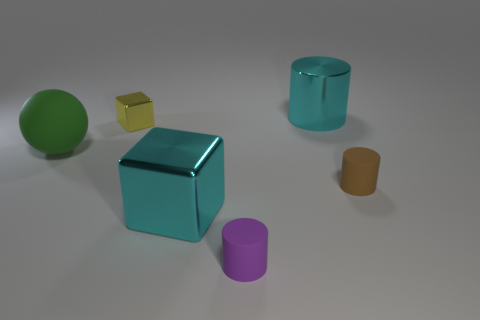Subtract all brown rubber cylinders. How many cylinders are left? 2 Subtract 1 cylinders. How many cylinders are left? 2 Add 4 large red cylinders. How many objects exist? 10 Subtract all balls. How many objects are left? 5 Subtract 0 gray cylinders. How many objects are left? 6 Subtract all spheres. Subtract all tiny objects. How many objects are left? 2 Add 5 tiny cubes. How many tiny cubes are left? 6 Add 5 purple things. How many purple things exist? 6 